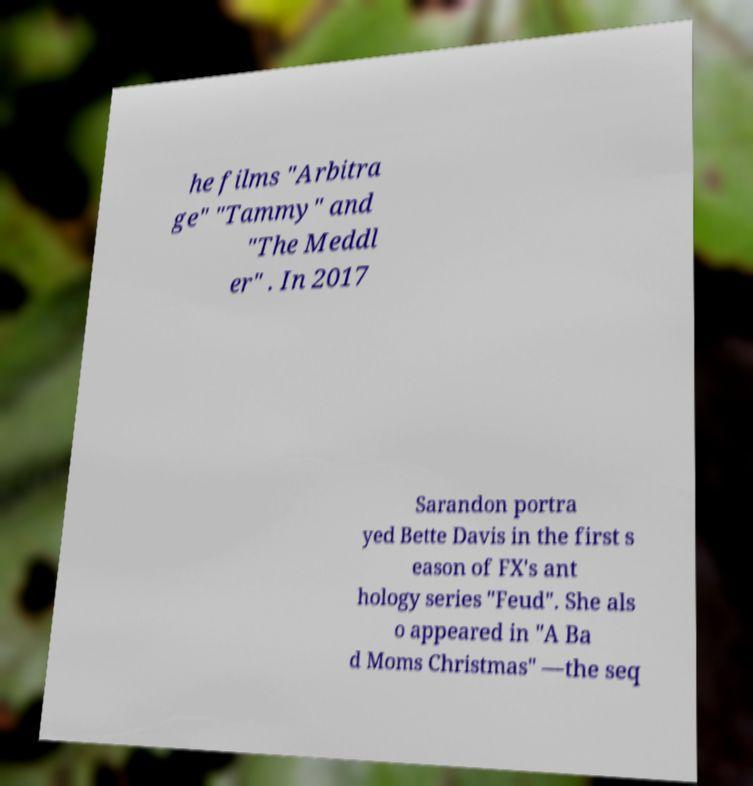Could you assist in decoding the text presented in this image and type it out clearly? he films "Arbitra ge" "Tammy" and "The Meddl er" . In 2017 Sarandon portra yed Bette Davis in the first s eason of FX's ant hology series "Feud". She als o appeared in "A Ba d Moms Christmas" —the seq 